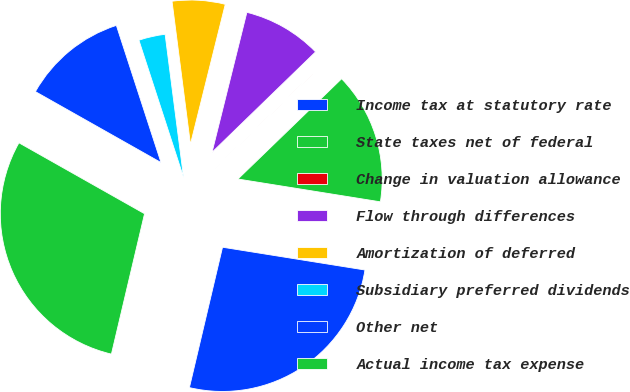Convert chart to OTSL. <chart><loc_0><loc_0><loc_500><loc_500><pie_chart><fcel>Income tax at statutory rate<fcel>State taxes net of federal<fcel>Change in valuation allowance<fcel>Flow through differences<fcel>Amortization of deferred<fcel>Subsidiary preferred dividends<fcel>Other net<fcel>Actual income tax expense<nl><fcel>26.16%<fcel>14.76%<fcel>0.02%<fcel>8.86%<fcel>5.92%<fcel>2.97%<fcel>11.81%<fcel>29.49%<nl></chart> 